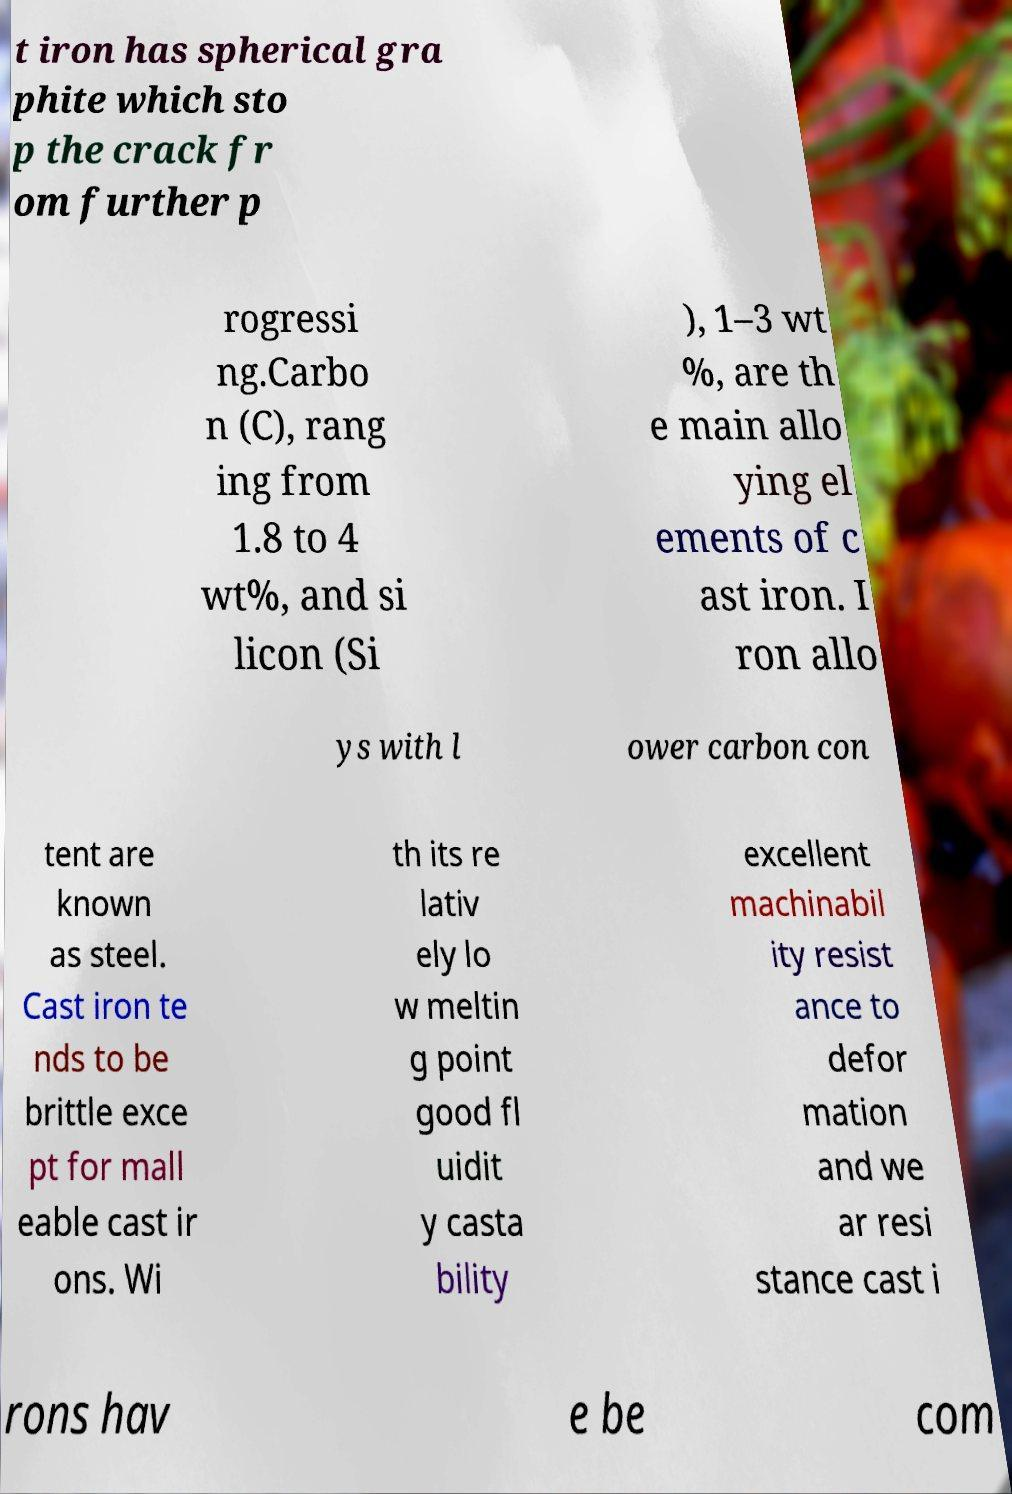Can you accurately transcribe the text from the provided image for me? t iron has spherical gra phite which sto p the crack fr om further p rogressi ng.Carbo n (C), rang ing from 1.8 to 4 wt%, and si licon (Si ), 1–3 wt %, are th e main allo ying el ements of c ast iron. I ron allo ys with l ower carbon con tent are known as steel. Cast iron te nds to be brittle exce pt for mall eable cast ir ons. Wi th its re lativ ely lo w meltin g point good fl uidit y casta bility excellent machinabil ity resist ance to defor mation and we ar resi stance cast i rons hav e be com 